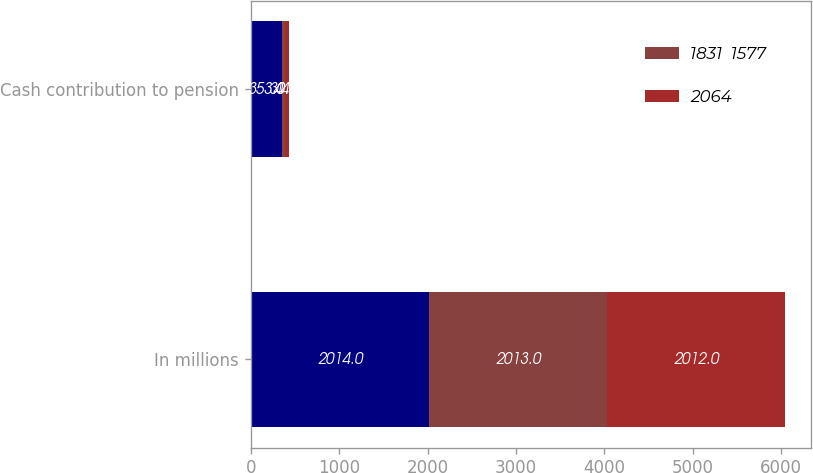Convert chart. <chart><loc_0><loc_0><loc_500><loc_500><stacked_bar_chart><ecel><fcel>In millions<fcel>Cash contribution to pension<nl><fcel>nan<fcel>2014<fcel>353<nl><fcel>1831  1577<fcel>2013<fcel>31<nl><fcel>2064<fcel>2012<fcel>44<nl></chart> 